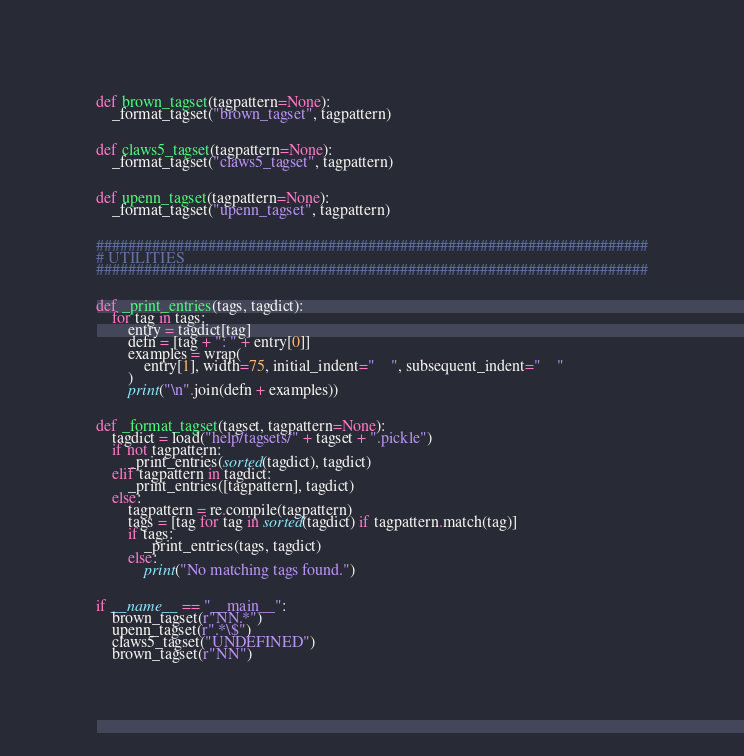<code> <loc_0><loc_0><loc_500><loc_500><_Python_>

def brown_tagset(tagpattern=None):
    _format_tagset("brown_tagset", tagpattern)


def claws5_tagset(tagpattern=None):
    _format_tagset("claws5_tagset", tagpattern)


def upenn_tagset(tagpattern=None):
    _format_tagset("upenn_tagset", tagpattern)


#####################################################################
# UTILITIES
#####################################################################


def _print_entries(tags, tagdict):
    for tag in tags:
        entry = tagdict[tag]
        defn = [tag + ": " + entry[0]]
        examples = wrap(
            entry[1], width=75, initial_indent="    ", subsequent_indent="    "
        )
        print("\n".join(defn + examples))


def _format_tagset(tagset, tagpattern=None):
    tagdict = load("help/tagsets/" + tagset + ".pickle")
    if not tagpattern:
        _print_entries(sorted(tagdict), tagdict)
    elif tagpattern in tagdict:
        _print_entries([tagpattern], tagdict)
    else:
        tagpattern = re.compile(tagpattern)
        tags = [tag for tag in sorted(tagdict) if tagpattern.match(tag)]
        if tags:
            _print_entries(tags, tagdict)
        else:
            print("No matching tags found.")


if __name__ == "__main__":
    brown_tagset(r"NN.*")
    upenn_tagset(r".*\$")
    claws5_tagset("UNDEFINED")
    brown_tagset(r"NN")
</code> 